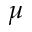<formula> <loc_0><loc_0><loc_500><loc_500>\mu</formula> 